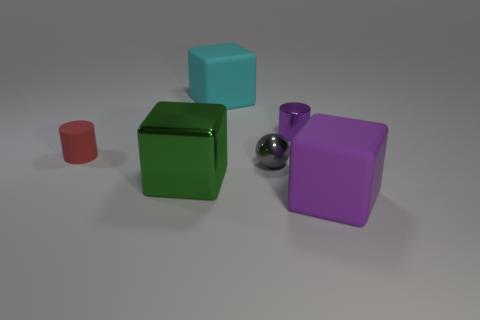Add 3 small cylinders. How many objects exist? 9 Subtract all red cylinders. How many cylinders are left? 1 Subtract all big green cubes. How many cubes are left? 2 Subtract all spheres. How many objects are left? 5 Subtract 1 cylinders. How many cylinders are left? 1 Subtract 0 brown balls. How many objects are left? 6 Subtract all green blocks. Subtract all red cylinders. How many blocks are left? 2 Subtract all brown spheres. How many cyan cubes are left? 1 Subtract all small red matte objects. Subtract all big cyan blocks. How many objects are left? 4 Add 3 big matte blocks. How many big matte blocks are left? 5 